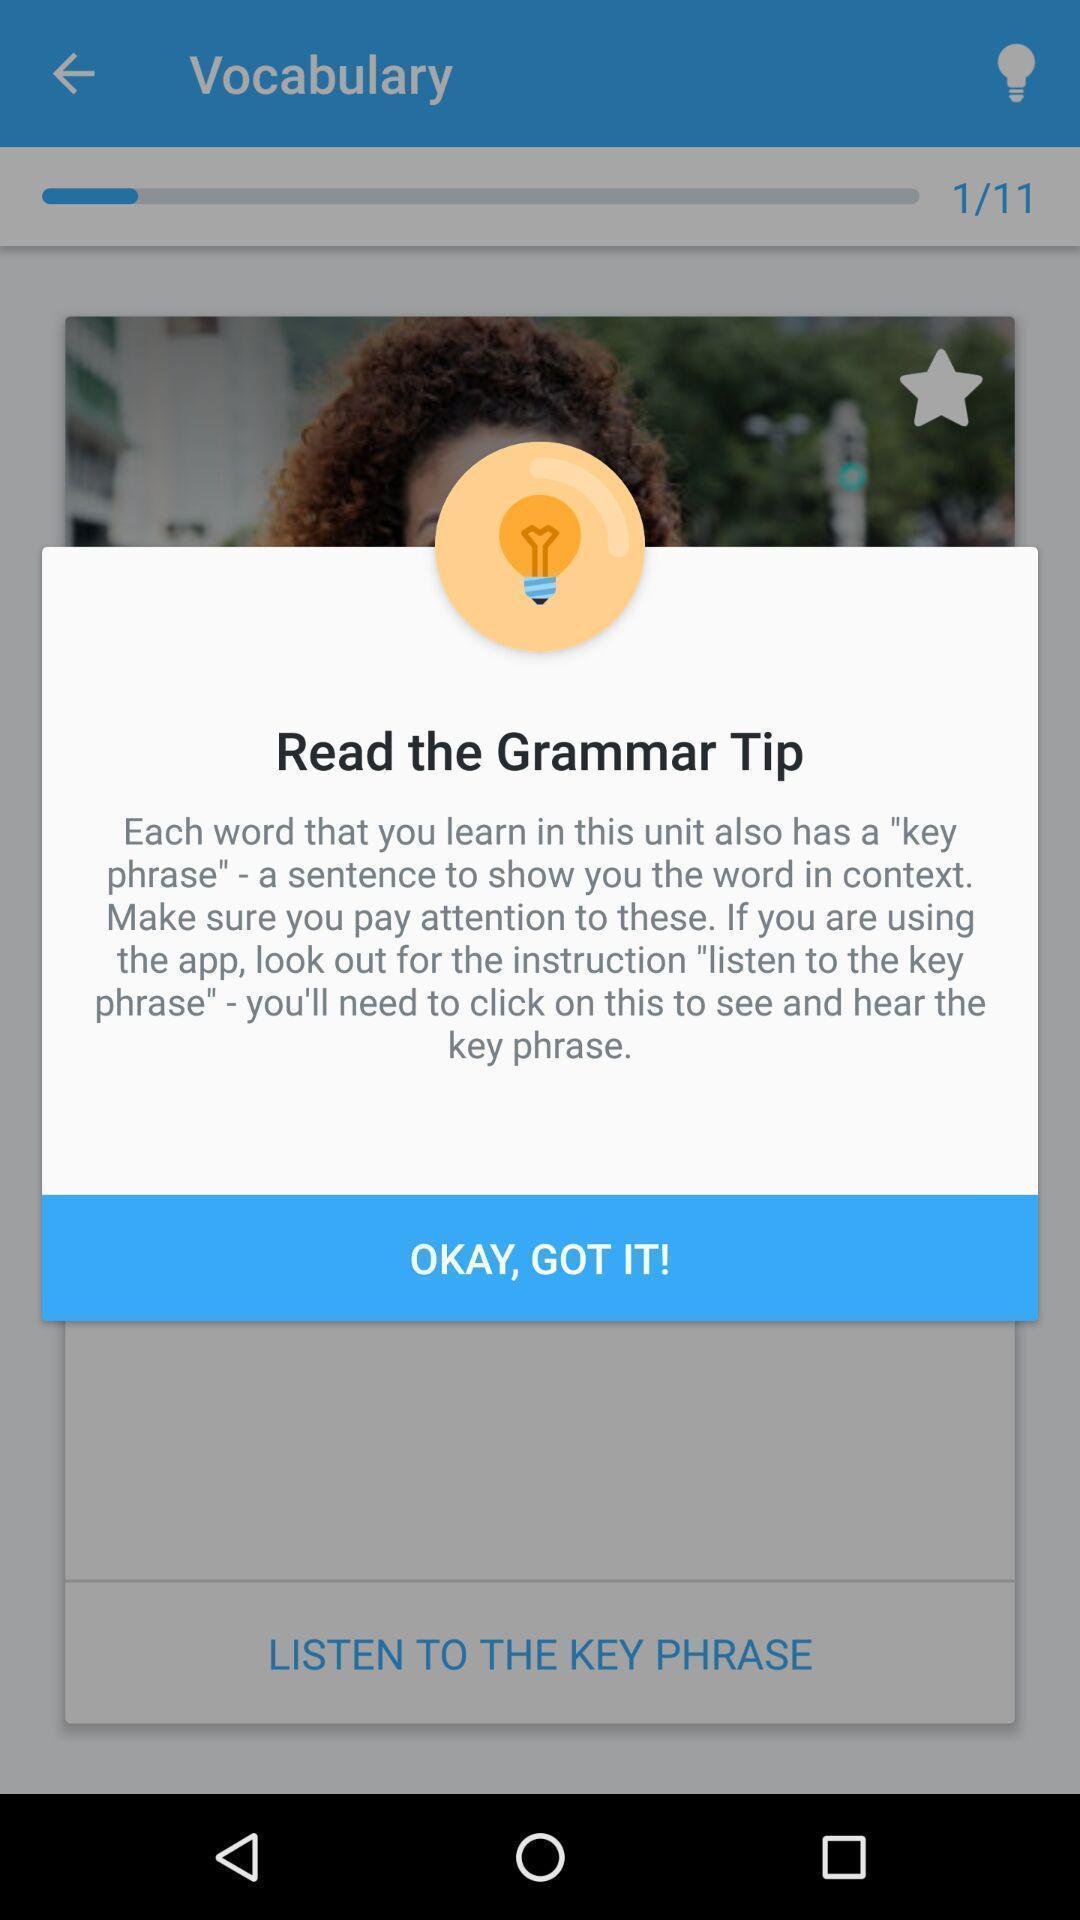What details can you identify in this image? Pop-up shows the grammar tip. 